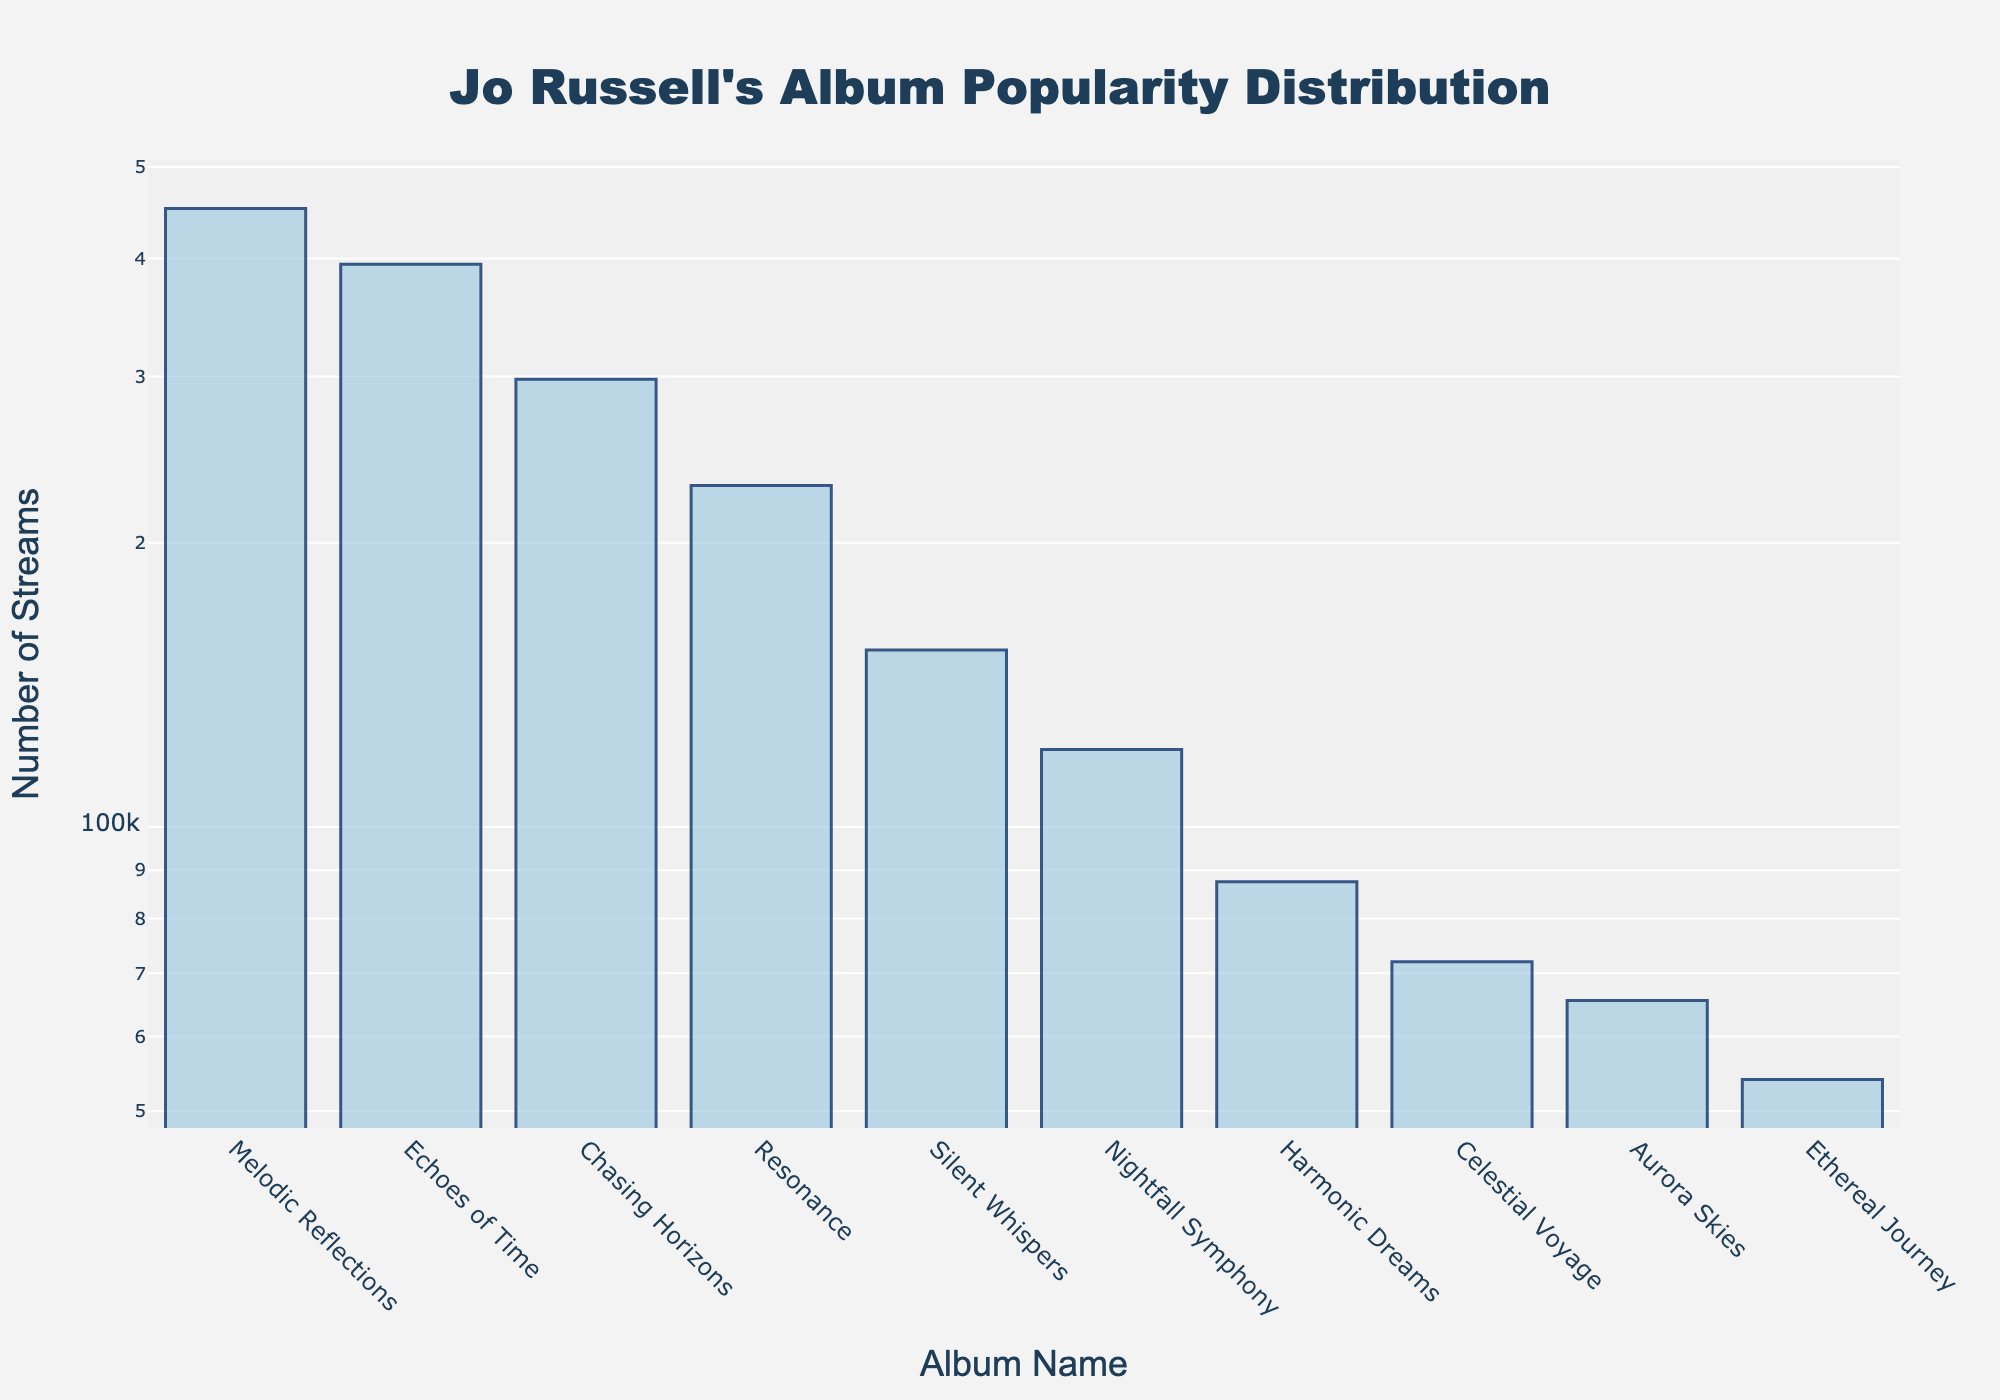what is the title of the plot? The title is mentioned at the top of the plot. It is typically the largest text that provides an overview of what the plot represents. In this case, the title is right at the top center.
Answer: Jo Russell's Album Popularity Distribution How many albums are visualized in the plot? By counting the bars displayed for each album name on the x-axis, you can determine the number of albums.
Answer: 10 What album has the highest number of streams? Look for the tallest bar in the plot, as it represents the album with the most streams. Verify by checking the hover text or y-axis value.
Answer: Melodic Reflections Which album has fewer streams, "Silent Whispers" or "Nightfall Symphony"? Compare the heights of the bars representing these two albums. The album with the shorter bar has fewer streams.
Answer: Nightfall Symphony What is the stream count difference between "Melodic Reflections" and "Ethereal Journey"? First, identify the stream numbers for both albums ("Melodic Reflections": 452,000 and "Ethereal Journey": 54,000). Subtract the smaller number from the larger one. 452,000 - 54,000 = 398,000
Answer: 398,000 On average, how many streams does Jo Russell's albums have? Add up all the stream numbers, and then divide by the total number of albums (10). Sum: 1,975,250. Divide by 10: 1,975,250 / 10 = 197,525
Answer: 197,525 Are there more albums with streams greater than or less than 120,000? Count the number of albums with stream numbers greater than 120,000 and those with less. Compare the counts to see which is higher.
Answer: More with less than 120,000 What is the median number of streams? Sort the stream numbers in ascending order and find the middle value. Because there are 10 albums, the median is the average of the 5th and 6th values in the sorted list (87,500 and 120,750). (87,500 + 120,750) / 2 = 104,125
Answer: 104,125 How much more popular is "Chasing Horizons" than "Aurora Skies" in terms of streams? Identify the stream counts for both albums ("Chasing Horizons": 298,000 and "Aurora Skies": 65,500). Subtract the smaller number from the larger one. 298,000 - 65,500 = 232,500
Answer: 232,500 Which album has the second highest number of streams? Locate the second tallest bar in the plot and check the album name associated with that bar.
Answer: Echoes of Time 